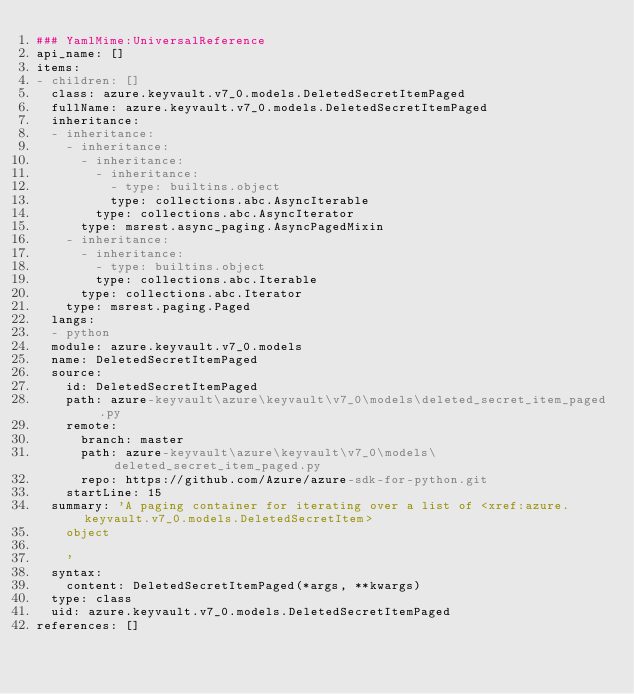<code> <loc_0><loc_0><loc_500><loc_500><_YAML_>### YamlMime:UniversalReference
api_name: []
items:
- children: []
  class: azure.keyvault.v7_0.models.DeletedSecretItemPaged
  fullName: azure.keyvault.v7_0.models.DeletedSecretItemPaged
  inheritance:
  - inheritance:
    - inheritance:
      - inheritance:
        - inheritance:
          - type: builtins.object
          type: collections.abc.AsyncIterable
        type: collections.abc.AsyncIterator
      type: msrest.async_paging.AsyncPagedMixin
    - inheritance:
      - inheritance:
        - type: builtins.object
        type: collections.abc.Iterable
      type: collections.abc.Iterator
    type: msrest.paging.Paged
  langs:
  - python
  module: azure.keyvault.v7_0.models
  name: DeletedSecretItemPaged
  source:
    id: DeletedSecretItemPaged
    path: azure-keyvault\azure\keyvault\v7_0\models\deleted_secret_item_paged.py
    remote:
      branch: master
      path: azure-keyvault\azure\keyvault\v7_0\models\deleted_secret_item_paged.py
      repo: https://github.com/Azure/azure-sdk-for-python.git
    startLine: 15
  summary: 'A paging container for iterating over a list of <xref:azure.keyvault.v7_0.models.DeletedSecretItem>
    object

    '
  syntax:
    content: DeletedSecretItemPaged(*args, **kwargs)
  type: class
  uid: azure.keyvault.v7_0.models.DeletedSecretItemPaged
references: []
</code> 